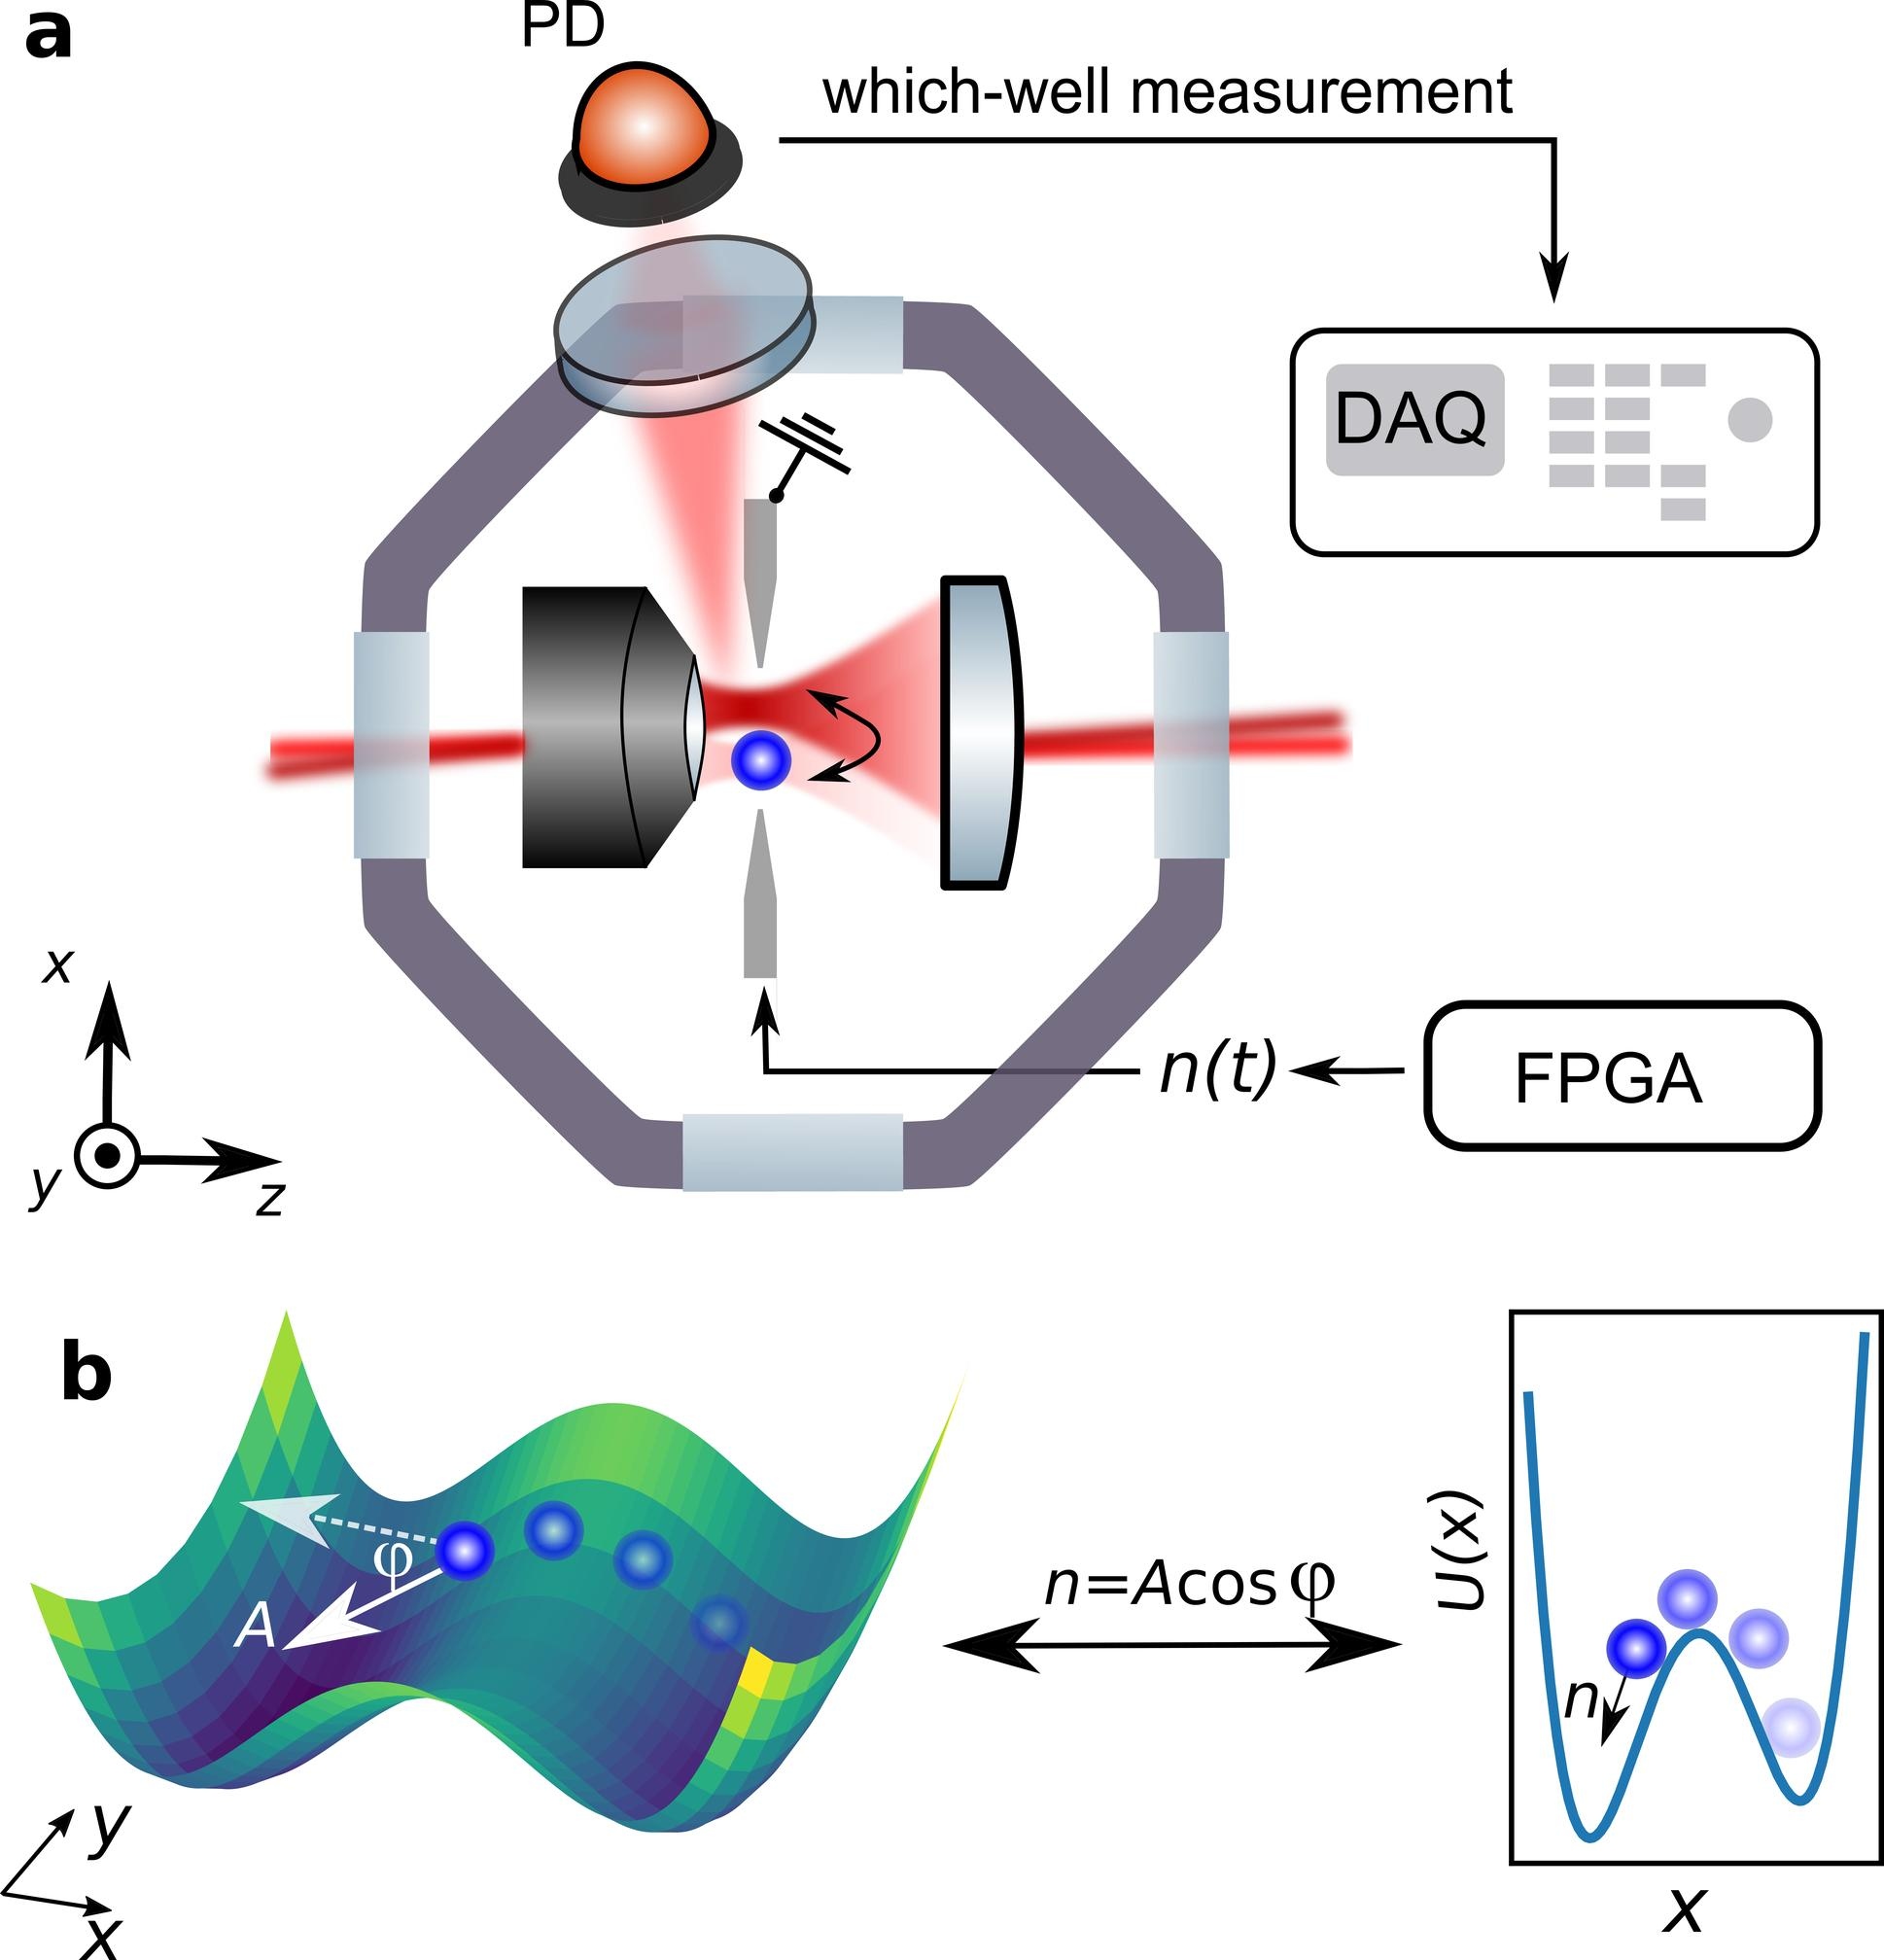Can we infer anything about the efficiency or limitation of the DAQ system from the setup shown? From the setup depicted in Figure a, we can infer that the DAQ (Data Acquisition) system is likely designed to handle high-resolution measurement and real-time data processing, key for capturing the rapid dynamics of the phenomena being studied. However, limitations might include the precision with which it can handle fluctuations or very minor changes in the state, as heavily dependent on the calibration of the DAQ and the sensitivity of the sensors used, such as the PD (Photodiode). 